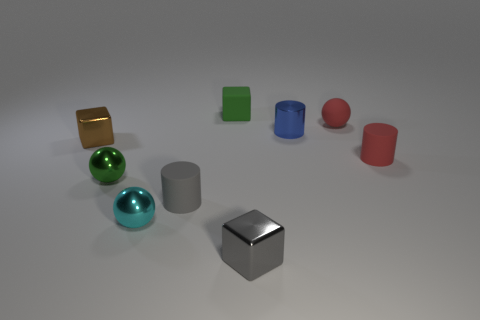Can you tell which object is the largest and which one is the smallest? Based on the image, the gold cube appears to be the largest object, and the tiny blue sphere seems to be the smallest. 